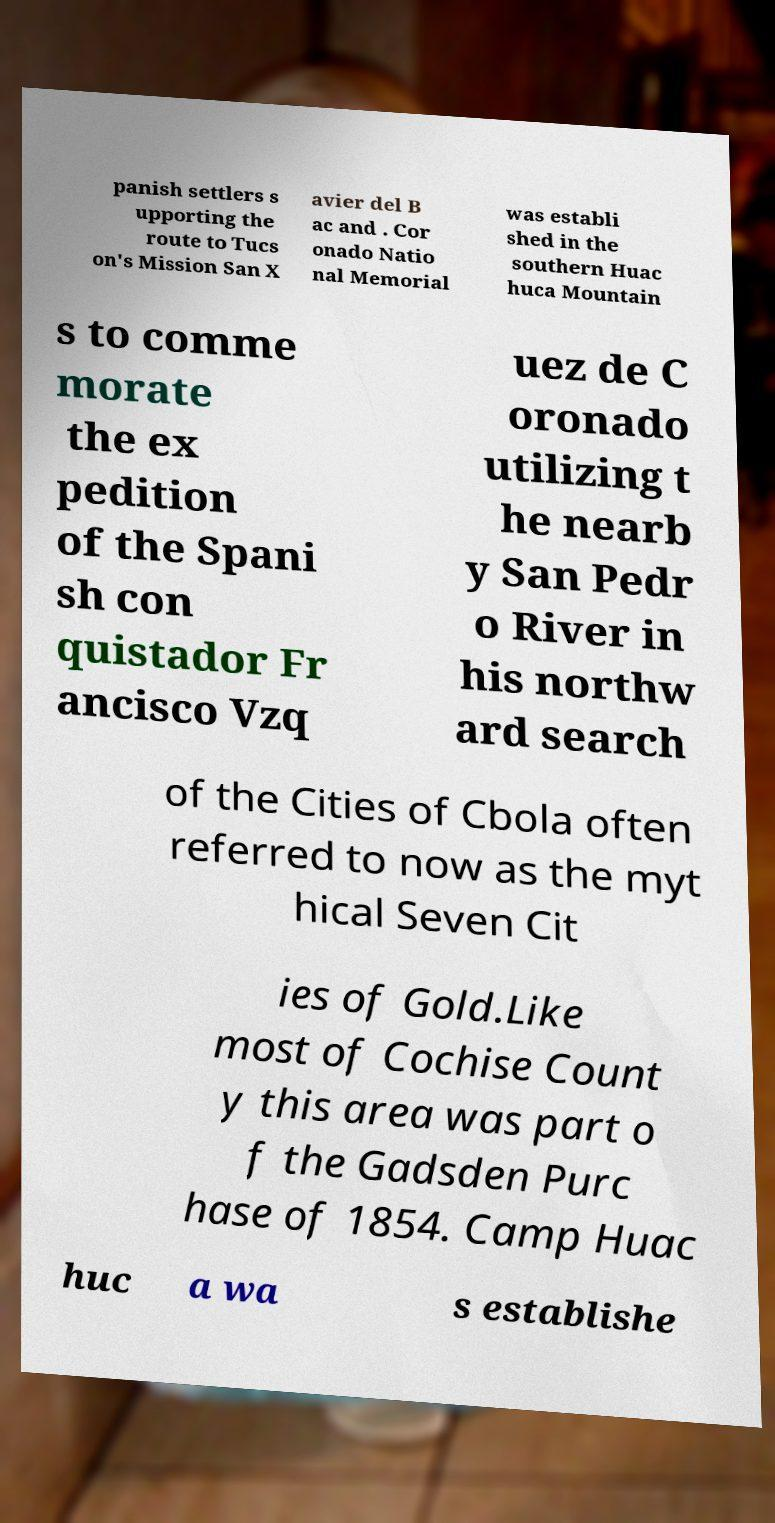Can you read and provide the text displayed in the image?This photo seems to have some interesting text. Can you extract and type it out for me? panish settlers s upporting the route to Tucs on's Mission San X avier del B ac and . Cor onado Natio nal Memorial was establi shed in the southern Huac huca Mountain s to comme morate the ex pedition of the Spani sh con quistador Fr ancisco Vzq uez de C oronado utilizing t he nearb y San Pedr o River in his northw ard search of the Cities of Cbola often referred to now as the myt hical Seven Cit ies of Gold.Like most of Cochise Count y this area was part o f the Gadsden Purc hase of 1854. Camp Huac huc a wa s establishe 